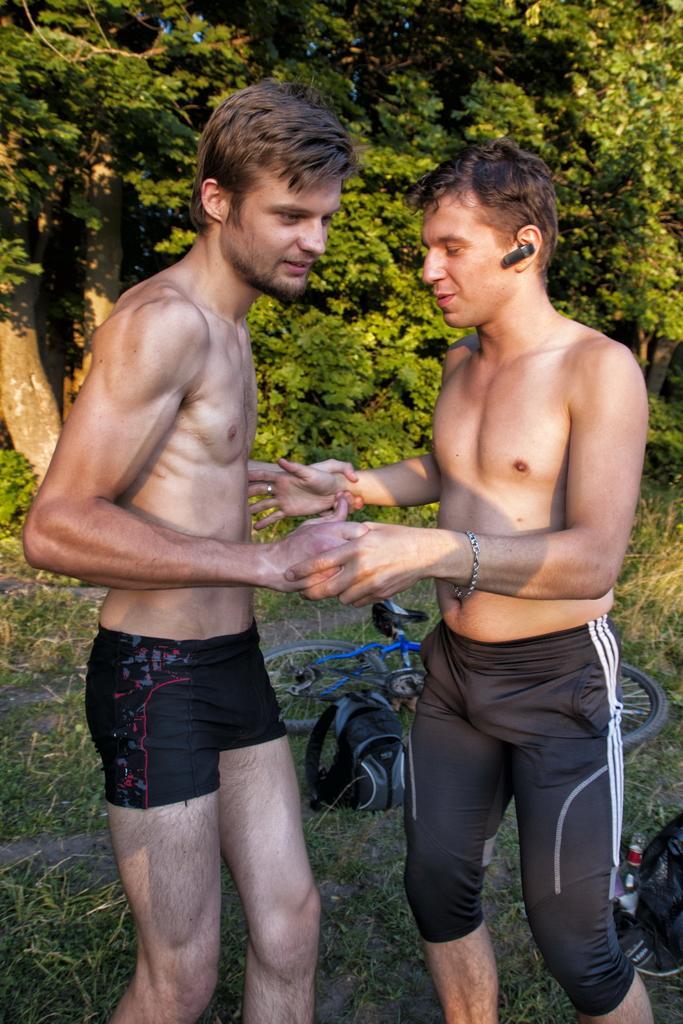Can you describe this image briefly? In this picture we can see two men standing in the front, in the background there are trees, we can see grass at the bottom. 